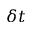<formula> <loc_0><loc_0><loc_500><loc_500>\delta t</formula> 